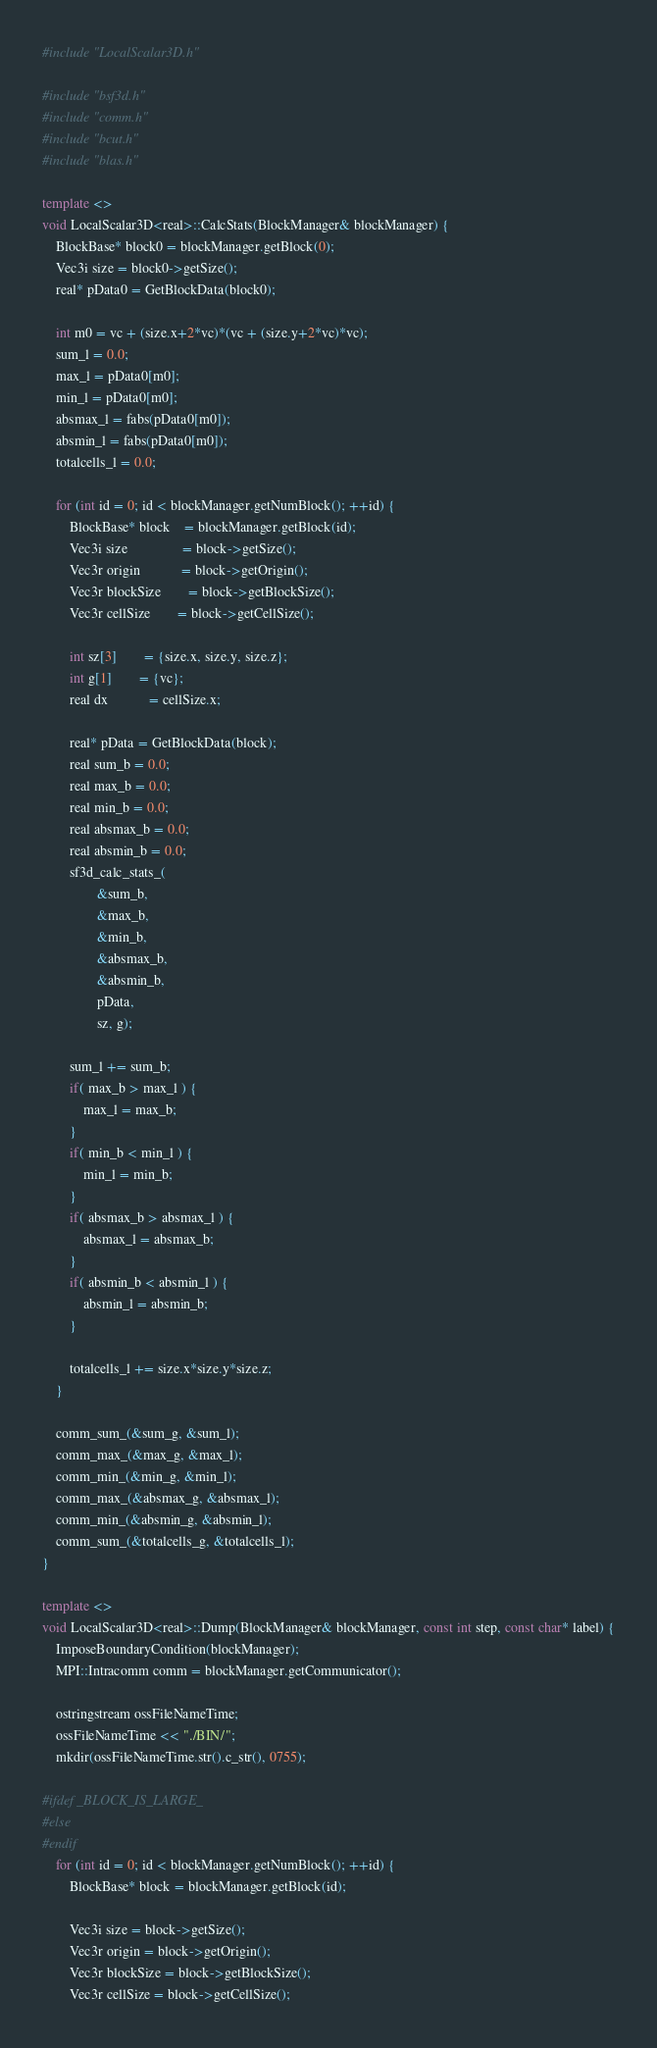Convert code to text. <code><loc_0><loc_0><loc_500><loc_500><_C++_>#include "LocalScalar3D.h"

#include "bsf3d.h"
#include "comm.h"
#include "bcut.h"
#include "blas.h"

template <>
void LocalScalar3D<real>::CalcStats(BlockManager& blockManager) {
	BlockBase* block0 = blockManager.getBlock(0);
	Vec3i size = block0->getSize();
	real* pData0 = GetBlockData(block0);

	int m0 = vc + (size.x+2*vc)*(vc + (size.y+2*vc)*vc);
	sum_l = 0.0;
	max_l = pData0[m0];
	min_l = pData0[m0];
	absmax_l = fabs(pData0[m0]);
	absmin_l = fabs(pData0[m0]);
	totalcells_l = 0.0;

	for (int id = 0; id < blockManager.getNumBlock(); ++id) {
		BlockBase* block	= blockManager.getBlock(id);
		Vec3i size				= block->getSize();
		Vec3r origin			= block->getOrigin();
		Vec3r blockSize		= block->getBlockSize();
		Vec3r cellSize		= block->getCellSize();

		int sz[3]		= {size.x, size.y, size.z};
		int g[1]		= {vc};
		real dx			= cellSize.x;

		real* pData = GetBlockData(block);
		real sum_b = 0.0;
		real max_b = 0.0;
		real min_b = 0.0;
		real absmax_b = 0.0;
		real absmin_b = 0.0;
		sf3d_calc_stats_(
				&sum_b,
				&max_b,
				&min_b,
				&absmax_b,
				&absmin_b,
				pData,
				sz, g);

		sum_l += sum_b;
		if( max_b > max_l ) {
			max_l = max_b;
		}
		if( min_b < min_l ) {
			min_l = min_b;
		}
		if( absmax_b > absmax_l ) {
			absmax_l = absmax_b;
		}
		if( absmin_b < absmin_l ) {
			absmin_l = absmin_b;
		}

		totalcells_l += size.x*size.y*size.z;
	}

	comm_sum_(&sum_g, &sum_l);
	comm_max_(&max_g, &max_l);
	comm_min_(&min_g, &min_l);
	comm_max_(&absmax_g, &absmax_l);
	comm_min_(&absmin_g, &absmin_l);
	comm_sum_(&totalcells_g, &totalcells_l);
}

template <>
void LocalScalar3D<real>::Dump(BlockManager& blockManager, const int step, const char* label) {
	ImposeBoundaryCondition(blockManager);
	MPI::Intracomm comm = blockManager.getCommunicator();

	ostringstream ossFileNameTime;
	ossFileNameTime << "./BIN/";
	mkdir(ossFileNameTime.str().c_str(), 0755);

#ifdef _BLOCK_IS_LARGE_
#else
#endif
	for (int id = 0; id < blockManager.getNumBlock(); ++id) {
		BlockBase* block = blockManager.getBlock(id);

		Vec3i size = block->getSize();
		Vec3r origin = block->getOrigin();
		Vec3r blockSize = block->getBlockSize();
		Vec3r cellSize = block->getCellSize();</code> 